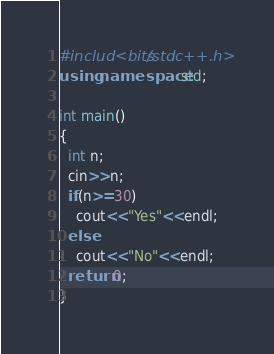<code> <loc_0><loc_0><loc_500><loc_500><_C++_>#includ<bits/stdc++.h>
using namespace std;

int main()
{
  int n;
  cin>>n;
  if(n>=30)
    cout<<"Yes"<<endl;
  else
    cout<<"No"<<endl;
  return 0;
}</code> 